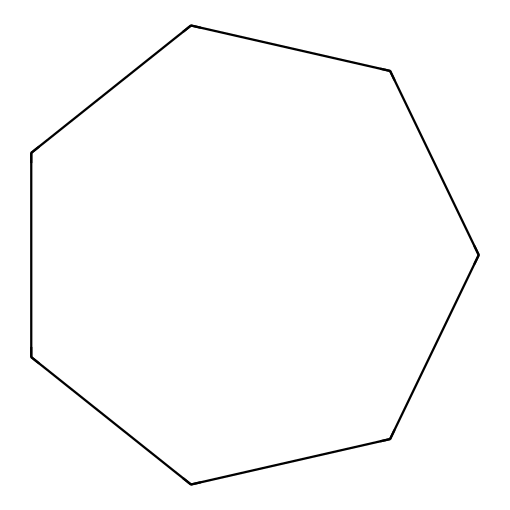What is the total number of carbon atoms in cycloheptane? In the SMILES representation, 'C' denotes carbon atoms. The structure includes 7 'C' which indicates a total of 7 carbon atoms.
Answer: 7 How many hydrogen atoms are present in cycloheptane? Every carbon in cycloheptane will typically bond with enough hydrogen atoms to complete four bonds. In a cycloalkane like cycloheptane, the general formula is CnH2n, where n is the number of carbon atoms. For n=7, the number of hydrogen atoms is 2(7)=14.
Answer: 14 What type of chemical structure is cycloheptane? Cycloheptane has a ring structure with carbon atoms connected in a cycle, which classifies it as a cycloalkane. This is characteristic of all cycloalkanes.
Answer: cycloalkane Does cycloheptane have any double bonds? In the structure of cycloheptane as depicted in the SMILES, there are only single bonds between the carbon atoms, consistent with cycloalkanes which contain no double bonds.
Answer: no What is the molecular formula of cycloheptane? The molecular formula is derived from the total number of each type of atom present. With 7 carbon atoms and 14 hydrogen atoms, the formula is C7H14.
Answer: C7H14 How many carbon-carbon single bonds are present in cycloheptane? In a cyclic structure like cycloheptane, each carbon atom is bonded to two other carbon atoms creating a single bond in each instance. Therefore, there are 7 carbon-carbon single bonds in cycloheptane.
Answer: 7 What type of strain can be found in the cycloheptane structure? Cycloheptane can exhibit angle strain due to its seven-membered ring, which does not perfectly allow tetrahedral angles (109.5 degrees) between adjacent carbon atoms, resulting in distorted bond angles.
Answer: angle strain 